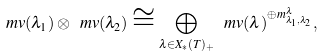Convert formula to latex. <formula><loc_0><loc_0><loc_500><loc_500>\ m v ( \lambda _ { 1 } ) \otimes \ m v ( \lambda _ { 2 } ) \cong \bigoplus _ { \lambda \in X _ { \ast } ( T ) _ { + } } \ m v ( \lambda ) ^ { \oplus m _ { \lambda _ { 1 } , \lambda _ { 2 } } ^ { \lambda } } ,</formula> 